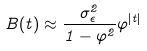<formula> <loc_0><loc_0><loc_500><loc_500>B ( t ) \approx \frac { \sigma _ { \epsilon } ^ { 2 } } { 1 - \varphi ^ { 2 } } \varphi ^ { | t | }</formula> 